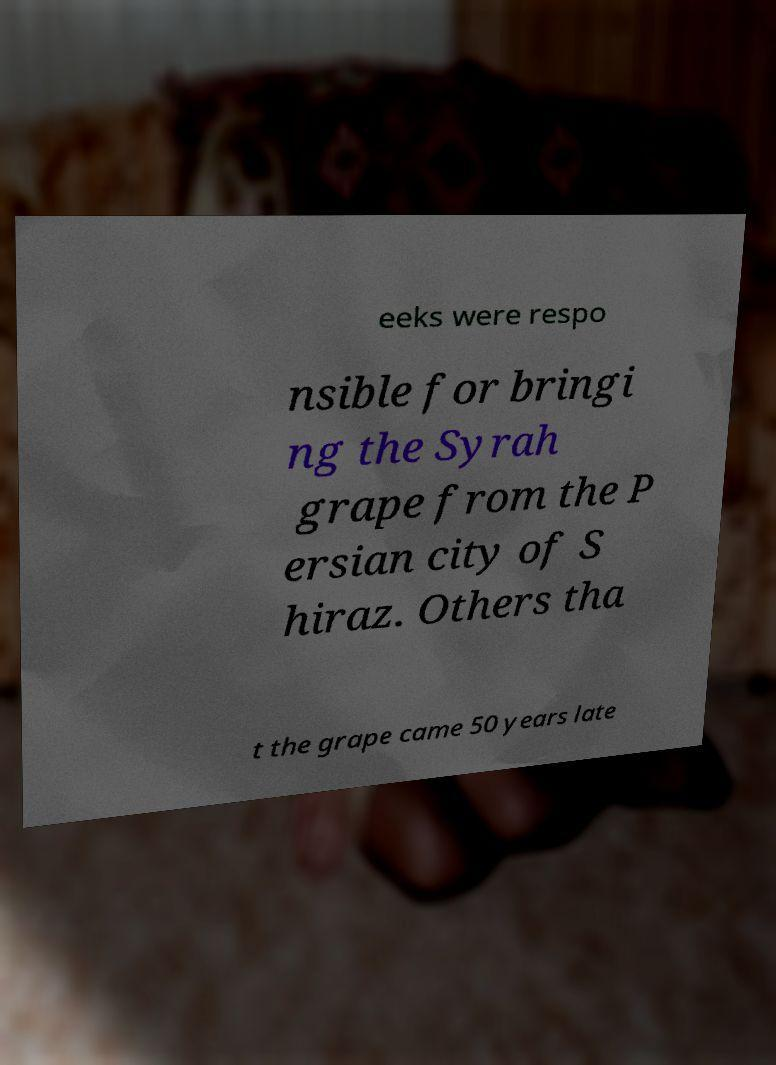There's text embedded in this image that I need extracted. Can you transcribe it verbatim? eeks were respo nsible for bringi ng the Syrah grape from the P ersian city of S hiraz. Others tha t the grape came 50 years late 